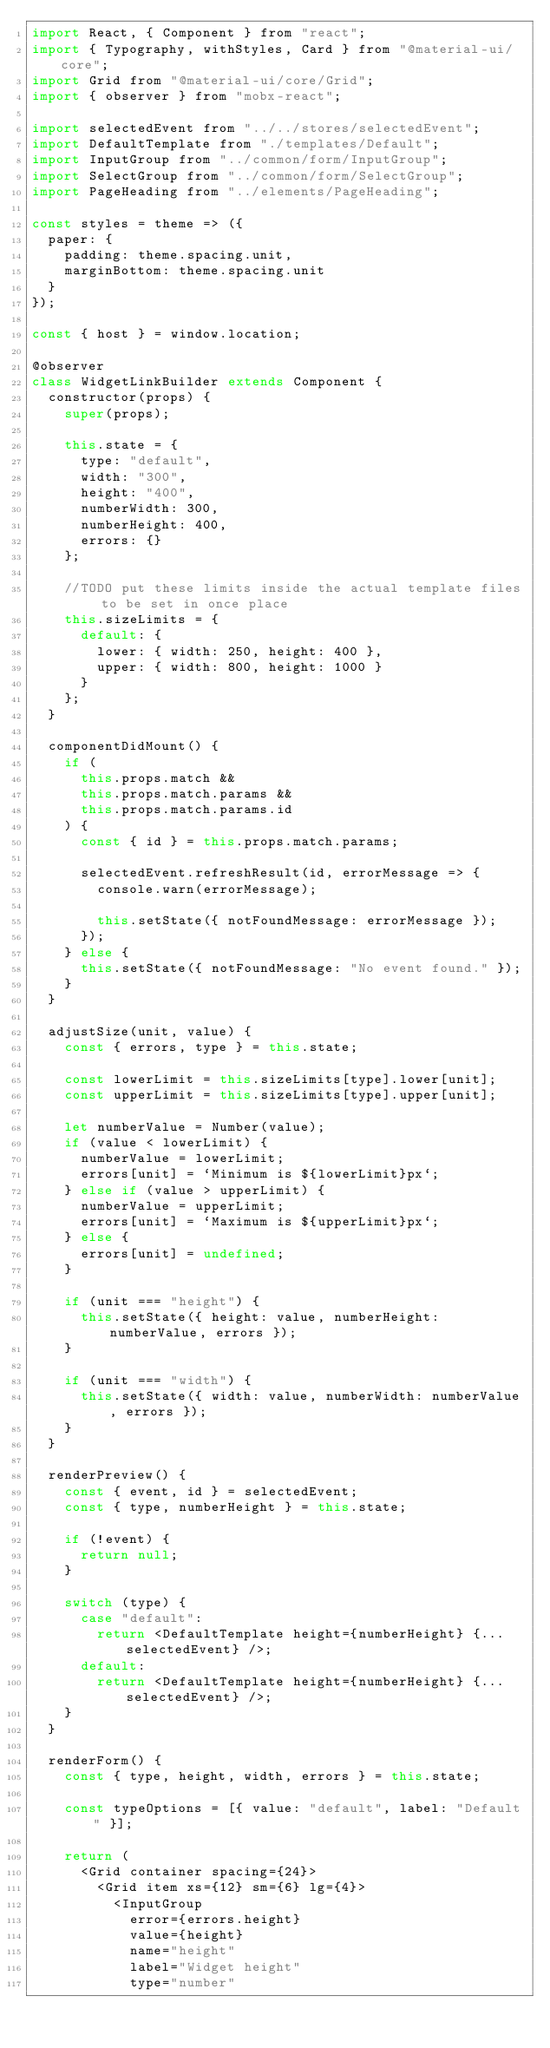<code> <loc_0><loc_0><loc_500><loc_500><_JavaScript_>import React, { Component } from "react";
import { Typography, withStyles, Card } from "@material-ui/core";
import Grid from "@material-ui/core/Grid";
import { observer } from "mobx-react";

import selectedEvent from "../../stores/selectedEvent";
import DefaultTemplate from "./templates/Default";
import InputGroup from "../common/form/InputGroup";
import SelectGroup from "../common/form/SelectGroup";
import PageHeading from "../elements/PageHeading";

const styles = theme => ({
	paper: {
		padding: theme.spacing.unit,
		marginBottom: theme.spacing.unit
	}
});

const { host } = window.location;

@observer
class WidgetLinkBuilder extends Component {
	constructor(props) {
		super(props);

		this.state = {
			type: "default",
			width: "300",
			height: "400",
			numberWidth: 300,
			numberHeight: 400,
			errors: {}
		};

		//TODO put these limits inside the actual template files to be set in once place
		this.sizeLimits = {
			default: {
				lower: { width: 250, height: 400 },
				upper: { width: 800, height: 1000 }
			}
		};
	}

	componentDidMount() {
		if (
			this.props.match &&
			this.props.match.params &&
			this.props.match.params.id
		) {
			const { id } = this.props.match.params;

			selectedEvent.refreshResult(id, errorMessage => {
				console.warn(errorMessage);

				this.setState({ notFoundMessage: errorMessage });
			});
		} else {
			this.setState({ notFoundMessage: "No event found." });
		}
	}

	adjustSize(unit, value) {
		const { errors, type } = this.state;

		const lowerLimit = this.sizeLimits[type].lower[unit];
		const upperLimit = this.sizeLimits[type].upper[unit];

		let numberValue = Number(value);
		if (value < lowerLimit) {
			numberValue = lowerLimit;
			errors[unit] = `Minimum is ${lowerLimit}px`;
		} else if (value > upperLimit) {
			numberValue = upperLimit;
			errors[unit] = `Maximum is ${upperLimit}px`;
		} else {
			errors[unit] = undefined;
		}

		if (unit === "height") {
			this.setState({ height: value, numberHeight: numberValue, errors });
		}

		if (unit === "width") {
			this.setState({ width: value, numberWidth: numberValue, errors });
		}
	}

	renderPreview() {
		const { event, id } = selectedEvent;
		const { type, numberHeight } = this.state;

		if (!event) {
			return null;
		}

		switch (type) {
			case "default":
				return <DefaultTemplate height={numberHeight} {...selectedEvent} />;
			default:
				return <DefaultTemplate height={numberHeight} {...selectedEvent} />;
		}
	}

	renderForm() {
		const { type, height, width, errors } = this.state;

		const typeOptions = [{ value: "default", label: "Default" }];

		return (
			<Grid container spacing={24}>
				<Grid item xs={12} sm={6} lg={4}>
					<InputGroup
						error={errors.height}
						value={height}
						name="height"
						label="Widget height"
						type="number"</code> 